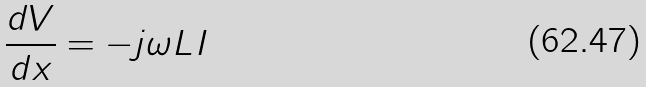Convert formula to latex. <formula><loc_0><loc_0><loc_500><loc_500>\frac { d V } { d x } = - j \omega L I</formula> 